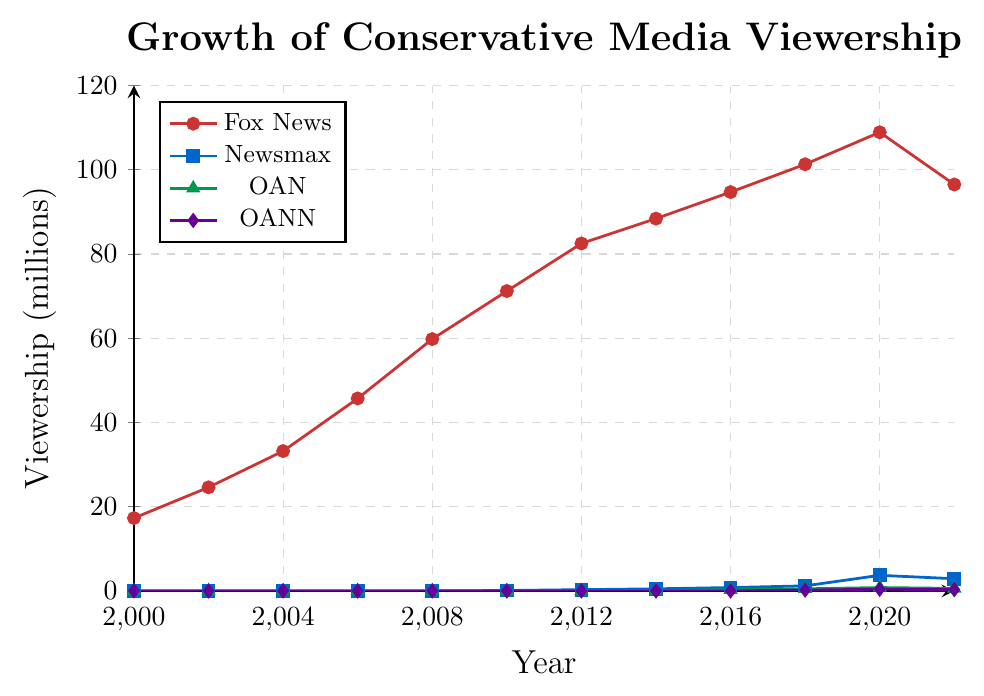What year did Fox News achieve its peak viewership as shown in the figure? By looking at the red line representing Fox News, we see that its highest point on the y-axis is in 2020. After that, it declines in 2022.
Answer: 2020 How many years after its launch did Newsmax first appear in the viewership data? Newsmax first appears in 2010. Since the data starts in 2000, it indicates that it took about 10 years for Newsmax to show up in the viewership data.
Answer: 10 years What is the difference in viewership between Fox News and Newsmax in 2020? In 2020, Fox News had a viewership of 108.9 million, while Newsmax had 3.7 million. The difference is 108.9 - 3.7 = 105.2 million.
Answer: 105.2 million Which network showed a decline in viewership between the years 2020 and 2022? By inspecting the lines, we see that Fox News, Newsmax, OAN, and OANN all show a decrease in viewership from 2020 to 2022.
Answer: Fox News, Newsmax, OAN, OANN What is the average viewership of Fox News from 2010 to 2020? The viewership numbers for Fox News from 2010 to 2020 are 71.2, 82.5, 88.4, 94.7, 101.3, 108.9. The average is calculated as (71.2+82.5+88.4+94.7+101.3+108.9)/6 = 90.333 million.
Answer: 90.3 million (rounded) Which network has the least viewership throughout the entire dataset? By examining the lines, we see that OANN (purple line) has the lowest viewership numbers throughout the dataset.
Answer: OANN How does the growth pattern of OAN compare to Newsmax from 2014 to 2020? From 2014 to 2020, both networks start with low viewership but grow over time. OAN grows from 0.1 to 0.8 million, while Newsmax grows faster from 0.5 to 3.7 million. This indicates that Newsmax had a faster growth rate compared to OAN.
Answer: Newsmax grew faster In which year did OAN first exceed a viewership of 0.5 million? By looking at the green line, we see that OAN first exceeded 0.5 million in the year 2018.
Answer: 2018 What is the combined viewership of all networks in 2022? In 2022, the viewership for Fox News, Newsmax, OAN, and OANN is 96.5, 2.9, 0.6, and 0.3 million, respectively. The combined viewership is 96.5+2.9+0.6+0.3=100.3 million.
Answer: 100.3 million Between which two consecutive years did Fox News see the highest increase in viewership? By examining the red line, the highest increase is between 2008 (59.8 million) and 2010 (71.2 million). The increase is 71.2 - 59.8 = 11.4 million.
Answer: 2008-2010 